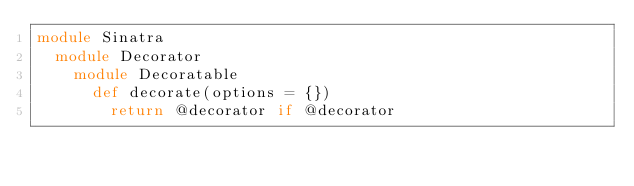<code> <loc_0><loc_0><loc_500><loc_500><_Ruby_>module Sinatra
  module Decorator
    module Decoratable
      def decorate(options = {})
        return @decorator if @decorator
</code> 